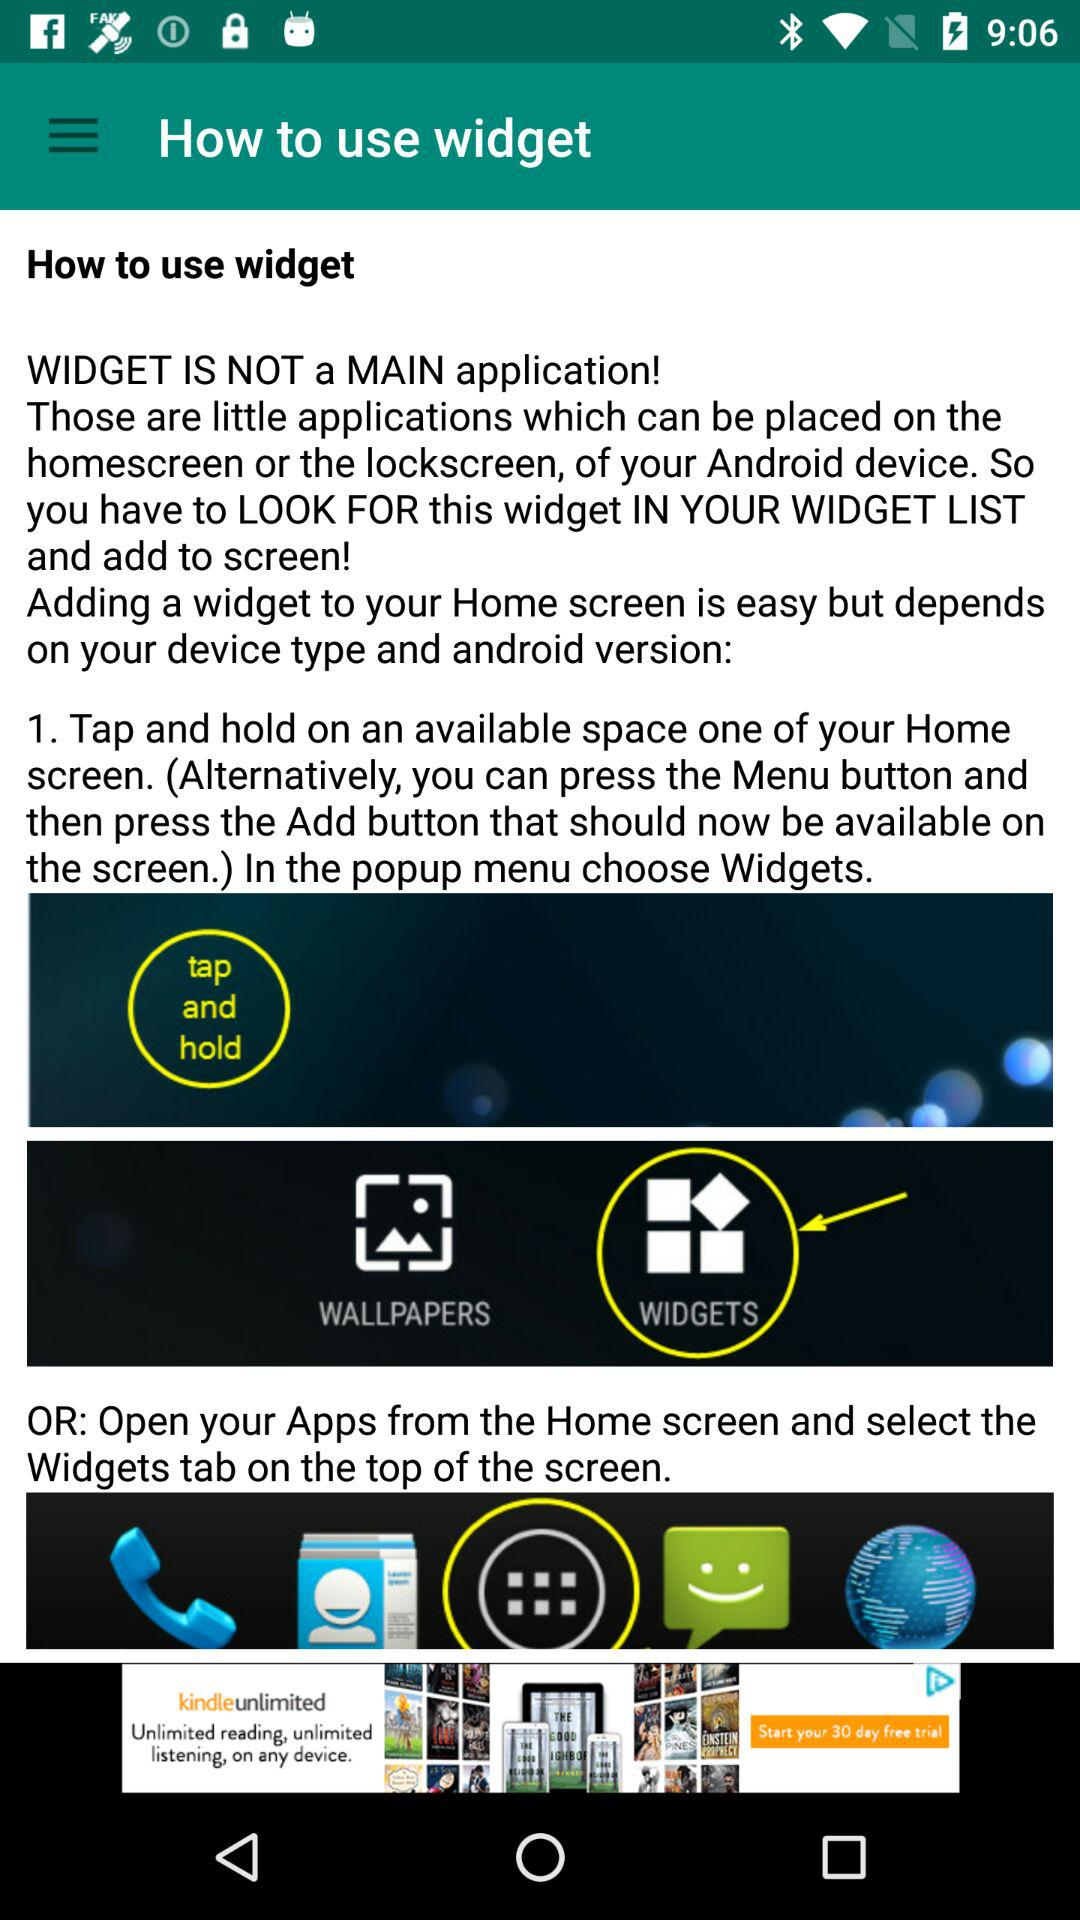What is widgets?
When the provided information is insufficient, respond with <no answer>. <no answer> 